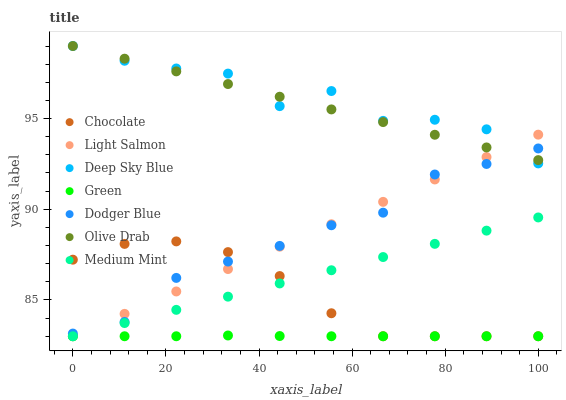Does Green have the minimum area under the curve?
Answer yes or no. Yes. Does Deep Sky Blue have the maximum area under the curve?
Answer yes or no. Yes. Does Light Salmon have the minimum area under the curve?
Answer yes or no. No. Does Light Salmon have the maximum area under the curve?
Answer yes or no. No. Is Olive Drab the smoothest?
Answer yes or no. Yes. Is Deep Sky Blue the roughest?
Answer yes or no. Yes. Is Light Salmon the smoothest?
Answer yes or no. No. Is Light Salmon the roughest?
Answer yes or no. No. Does Medium Mint have the lowest value?
Answer yes or no. Yes. Does Dodger Blue have the lowest value?
Answer yes or no. No. Does Olive Drab have the highest value?
Answer yes or no. Yes. Does Light Salmon have the highest value?
Answer yes or no. No. Is Green less than Olive Drab?
Answer yes or no. Yes. Is Dodger Blue greater than Green?
Answer yes or no. Yes. Does Medium Mint intersect Green?
Answer yes or no. Yes. Is Medium Mint less than Green?
Answer yes or no. No. Is Medium Mint greater than Green?
Answer yes or no. No. Does Green intersect Olive Drab?
Answer yes or no. No. 